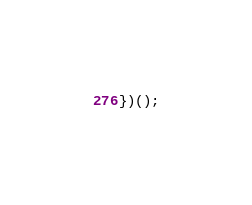Convert code to text. <code><loc_0><loc_0><loc_500><loc_500><_JavaScript_>})();

</code> 